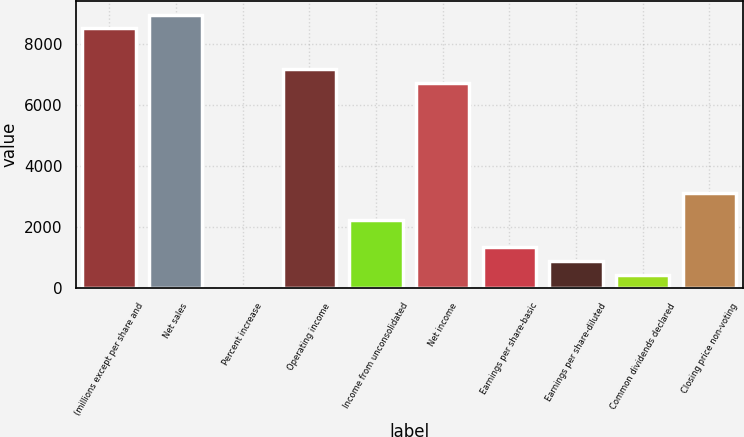Convert chart to OTSL. <chart><loc_0><loc_0><loc_500><loc_500><bar_chart><fcel>(millions except per share and<fcel>Net sales<fcel>Percent increase<fcel>Operating income<fcel>Income from unconsolidated<fcel>Net income<fcel>Earnings per share-basic<fcel>Earnings per share-diluted<fcel>Common dividends declared<fcel>Closing price non-voting<nl><fcel>8496.77<fcel>8943.9<fcel>1.3<fcel>7155.38<fcel>2236.95<fcel>6708.25<fcel>1342.69<fcel>895.56<fcel>448.43<fcel>3131.21<nl></chart> 